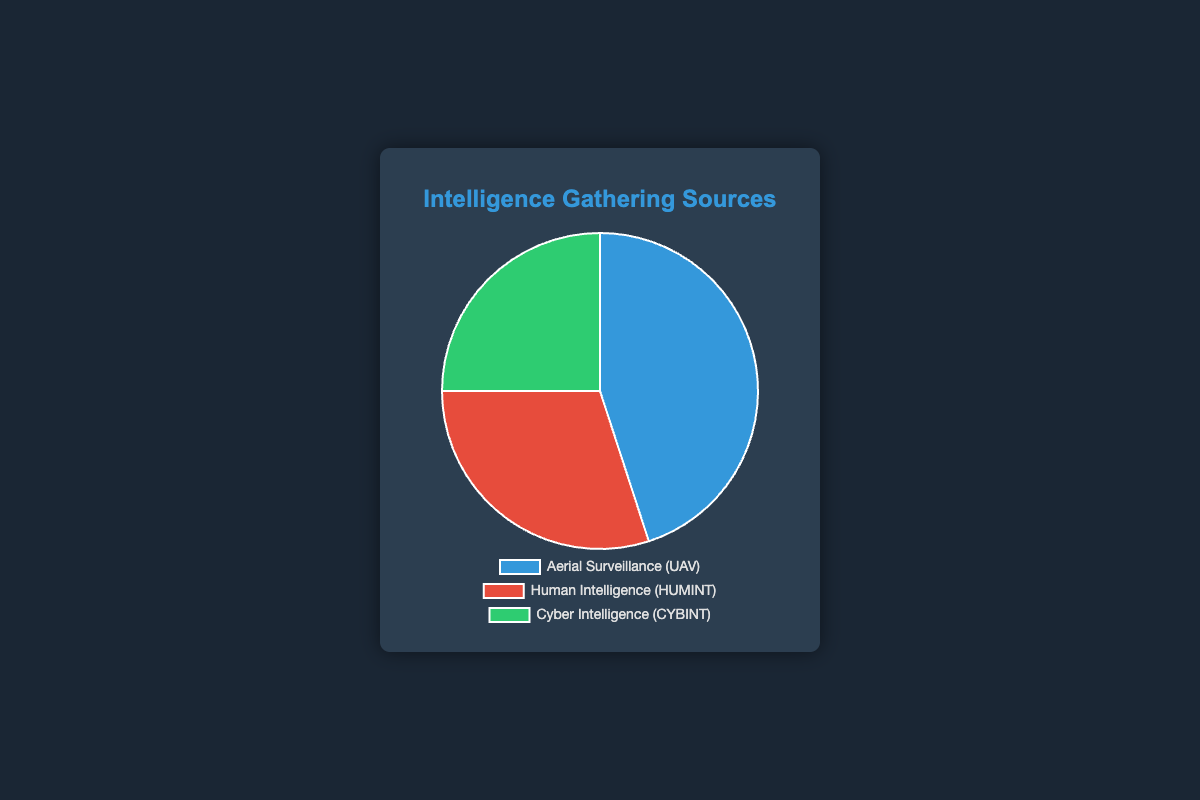Which intelligence gathering source has the highest contribution percentage? The pie chart shows that Aerial Surveillance (UAV) has the largest segment, represented with 45%.
Answer: Aerial Surveillance (UAV) What is the combined percentage contribution of HUMINT and CYBINT? Adding the percentages of Human Intelligence (HUMINT) and Cyber Intelligence (CYBINT) gives us 30% + 25% = 55%.
Answer: 55% Which intelligence gathering source has the smallest percentage share? The smallest segment in the pie chart is Cyber Intelligence (CYBINT) with 25%.
Answer: Cyber Intelligence (CYBINT) How much greater is the UAV contribution compared to the CYBINT contribution? Subtracting the percentage of Cyber Intelligence (CYBINT) from Aerial Surveillance (UAV) gives us 45% - 25% = 20%.
Answer: 20% What is the difference in percentage between the largest and the smallest intelligence gathering sources? The difference between Aerial Surveillance (45%) and Cyber Intelligence (25%) is 45% - 25% = 20%.
Answer: 20% What color represents the Human Intelligence (HUMINT) data in the chart? The pie chart uses red to represent Human Intelligence (HUMINT).
Answer: Red If the combined percentage of Aerial Surveillance and CYBINT were to be evenly split, what would each contribute? The combined percentage is 45% (Aerial Surveillance) + 25% (CYBINT) = 70%. Dividing this evenly, each would contribute 70% / 2 = 35%.
Answer: 35% What is the average percentage contribution of all intelligence gathering sources in the chart? Adding all percentages results in 45% + 30% + 25% = 100%. The average contribution is 100% / 3 = approximately 33.33%.
Answer: 33.33% Which sources combine to form a larger share than the largest single source? Human Intelligence (30%) and Cyber Intelligence (25%) together form 55%, which is larger than the largest single source, Aerial Surveillance at 45%.
Answer: Human Intelligence and Cyber Intelligence What portion of the chart is not represented by Human Intelligence (HUMINT)? The total chart is 100%. The portion not represented by Human Intelligence (HUMINT) is 100% - 30% = 70%.
Answer: 70% 